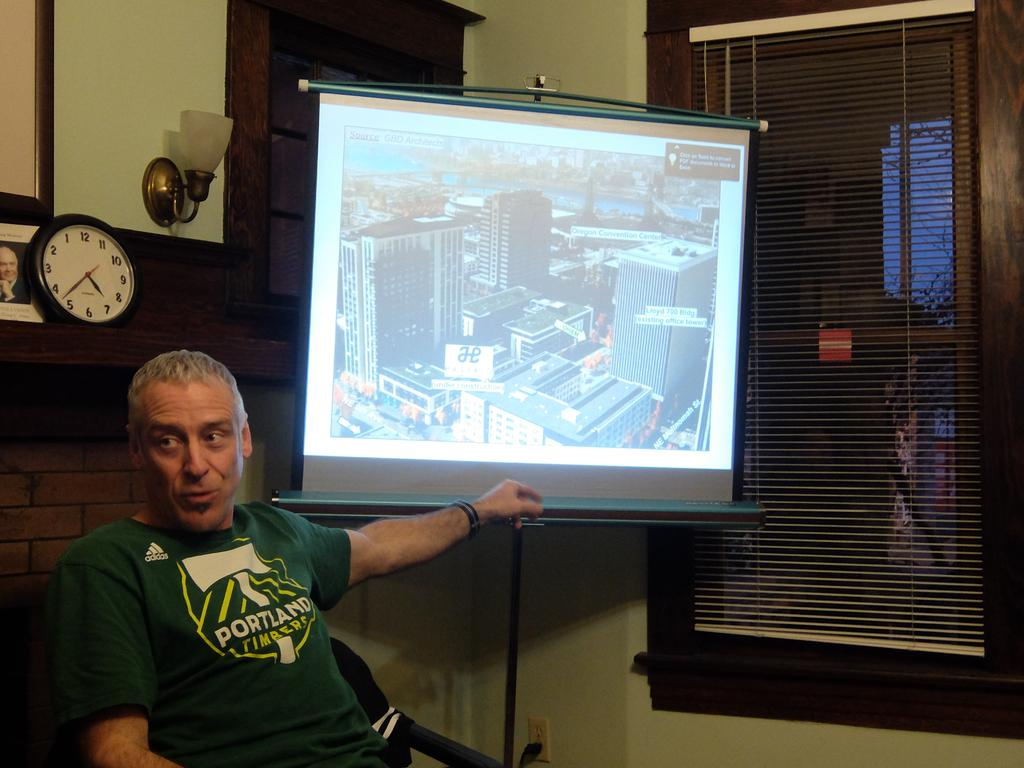<image>
Describe the image concisely. the word Portland is on the green shirt 